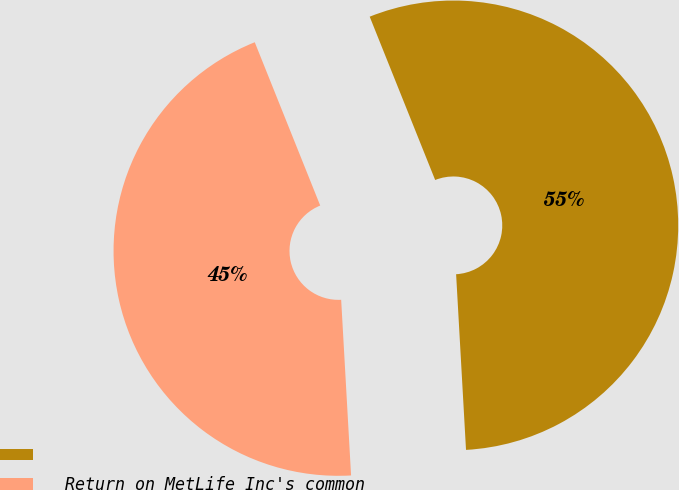<chart> <loc_0><loc_0><loc_500><loc_500><pie_chart><ecel><fcel>Return on MetLife Inc's common<nl><fcel>55.17%<fcel>44.83%<nl></chart> 